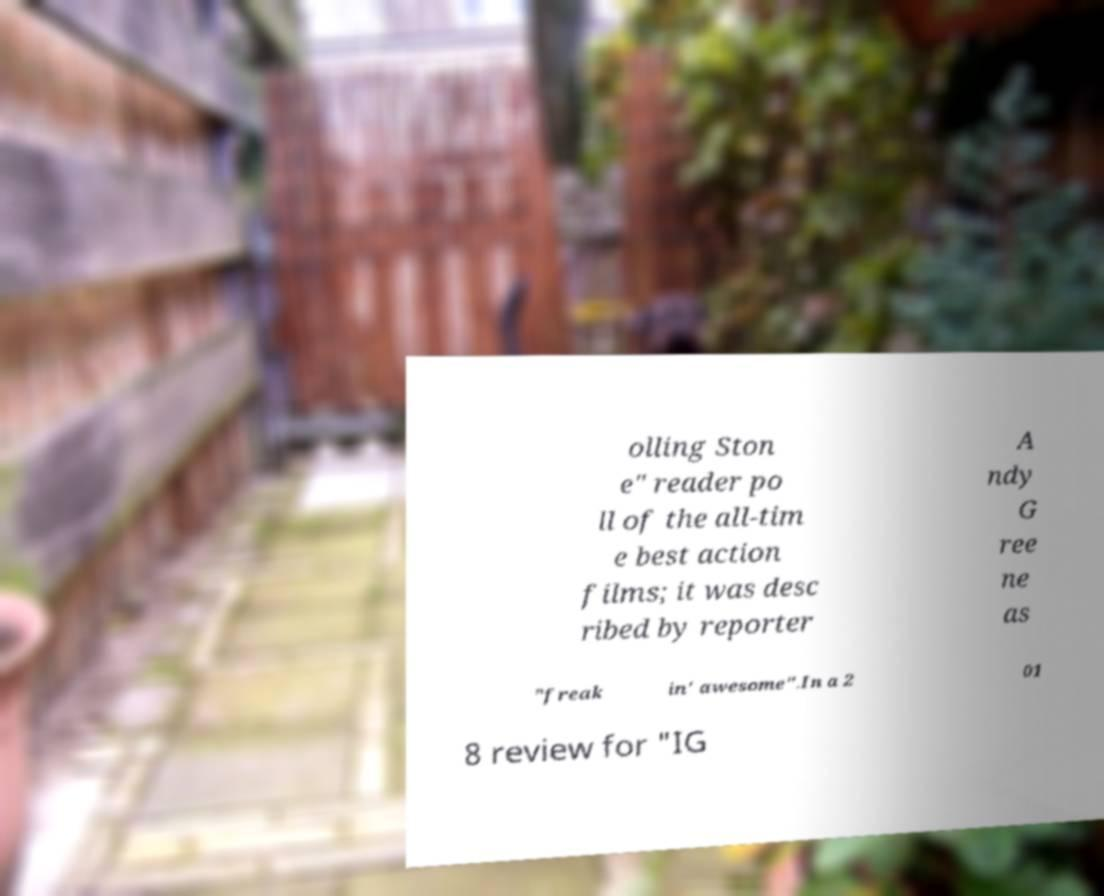What messages or text are displayed in this image? I need them in a readable, typed format. olling Ston e" reader po ll of the all-tim e best action films; it was desc ribed by reporter A ndy G ree ne as "freak in' awesome".In a 2 01 8 review for "IG 